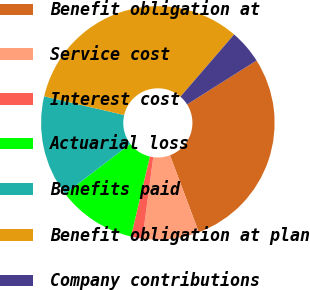<chart> <loc_0><loc_0><loc_500><loc_500><pie_chart><fcel>Benefit obligation at<fcel>Service cost<fcel>Interest cost<fcel>Actuarial loss<fcel>Benefits paid<fcel>Benefit obligation at plan<fcel>Company contributions<nl><fcel>28.27%<fcel>7.81%<fcel>1.59%<fcel>10.92%<fcel>14.03%<fcel>32.68%<fcel>4.7%<nl></chart> 